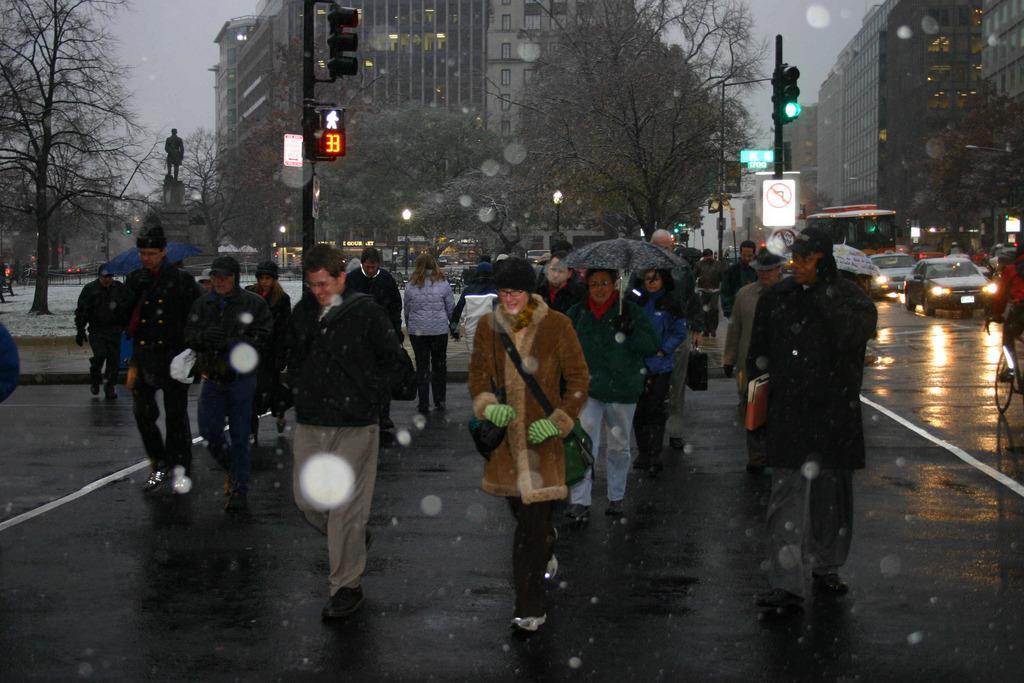How would you summarize this image in a sentence or two? In the center of the image there are people walking on the road. In the background of the image there are buildings. There are trees. There are traffic signals. There is a statue. There are cars and buses. 